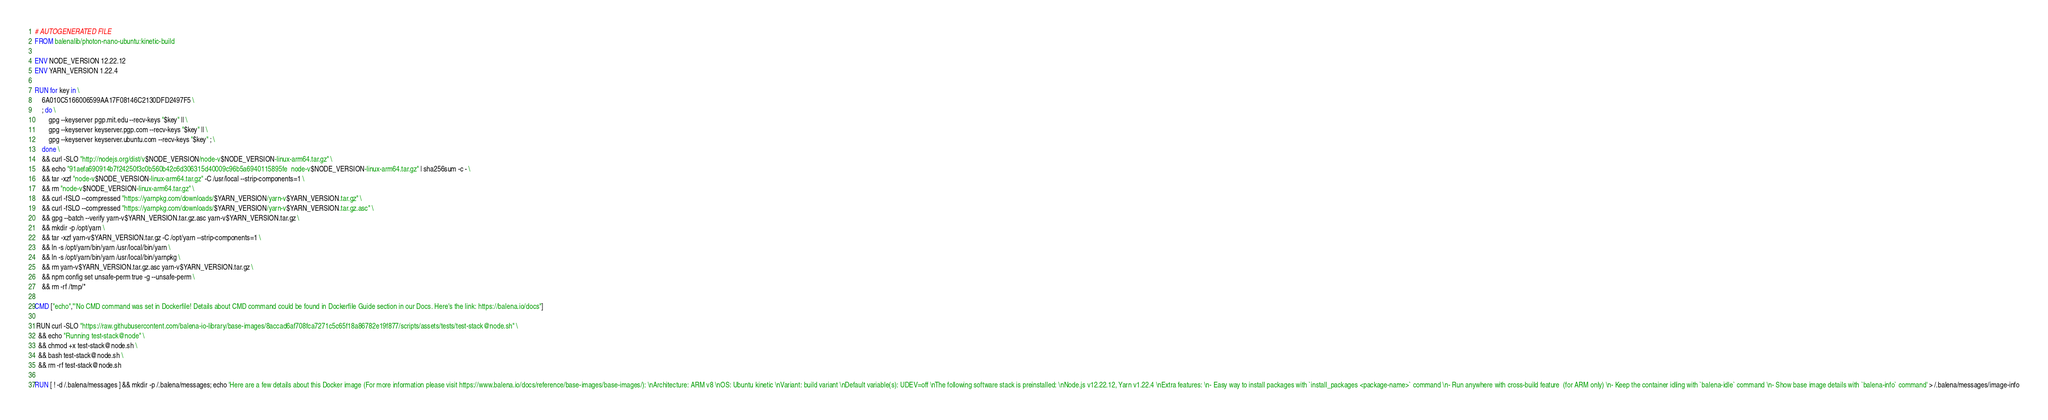<code> <loc_0><loc_0><loc_500><loc_500><_Dockerfile_># AUTOGENERATED FILE
FROM balenalib/photon-nano-ubuntu:kinetic-build

ENV NODE_VERSION 12.22.12
ENV YARN_VERSION 1.22.4

RUN for key in \
	6A010C5166006599AA17F08146C2130DFD2497F5 \
	; do \
		gpg --keyserver pgp.mit.edu --recv-keys "$key" || \
		gpg --keyserver keyserver.pgp.com --recv-keys "$key" || \
		gpg --keyserver keyserver.ubuntu.com --recv-keys "$key" ; \
	done \
	&& curl -SLO "http://nodejs.org/dist/v$NODE_VERSION/node-v$NODE_VERSION-linux-arm64.tar.gz" \
	&& echo "91aefa690914b7f24250f3c0b560b42c6d306315d40009c96b5a6940115895fe  node-v$NODE_VERSION-linux-arm64.tar.gz" | sha256sum -c - \
	&& tar -xzf "node-v$NODE_VERSION-linux-arm64.tar.gz" -C /usr/local --strip-components=1 \
	&& rm "node-v$NODE_VERSION-linux-arm64.tar.gz" \
	&& curl -fSLO --compressed "https://yarnpkg.com/downloads/$YARN_VERSION/yarn-v$YARN_VERSION.tar.gz" \
	&& curl -fSLO --compressed "https://yarnpkg.com/downloads/$YARN_VERSION/yarn-v$YARN_VERSION.tar.gz.asc" \
	&& gpg --batch --verify yarn-v$YARN_VERSION.tar.gz.asc yarn-v$YARN_VERSION.tar.gz \
	&& mkdir -p /opt/yarn \
	&& tar -xzf yarn-v$YARN_VERSION.tar.gz -C /opt/yarn --strip-components=1 \
	&& ln -s /opt/yarn/bin/yarn /usr/local/bin/yarn \
	&& ln -s /opt/yarn/bin/yarn /usr/local/bin/yarnpkg \
	&& rm yarn-v$YARN_VERSION.tar.gz.asc yarn-v$YARN_VERSION.tar.gz \
	&& npm config set unsafe-perm true -g --unsafe-perm \
	&& rm -rf /tmp/*

CMD ["echo","'No CMD command was set in Dockerfile! Details about CMD command could be found in Dockerfile Guide section in our Docs. Here's the link: https://balena.io/docs"]

 RUN curl -SLO "https://raw.githubusercontent.com/balena-io-library/base-images/8accad6af708fca7271c5c65f18a86782e19f877/scripts/assets/tests/test-stack@node.sh" \
  && echo "Running test-stack@node" \
  && chmod +x test-stack@node.sh \
  && bash test-stack@node.sh \
  && rm -rf test-stack@node.sh 

RUN [ ! -d /.balena/messages ] && mkdir -p /.balena/messages; echo 'Here are a few details about this Docker image (For more information please visit https://www.balena.io/docs/reference/base-images/base-images/): \nArchitecture: ARM v8 \nOS: Ubuntu kinetic \nVariant: build variant \nDefault variable(s): UDEV=off \nThe following software stack is preinstalled: \nNode.js v12.22.12, Yarn v1.22.4 \nExtra features: \n- Easy way to install packages with `install_packages <package-name>` command \n- Run anywhere with cross-build feature  (for ARM only) \n- Keep the container idling with `balena-idle` command \n- Show base image details with `balena-info` command' > /.balena/messages/image-info</code> 